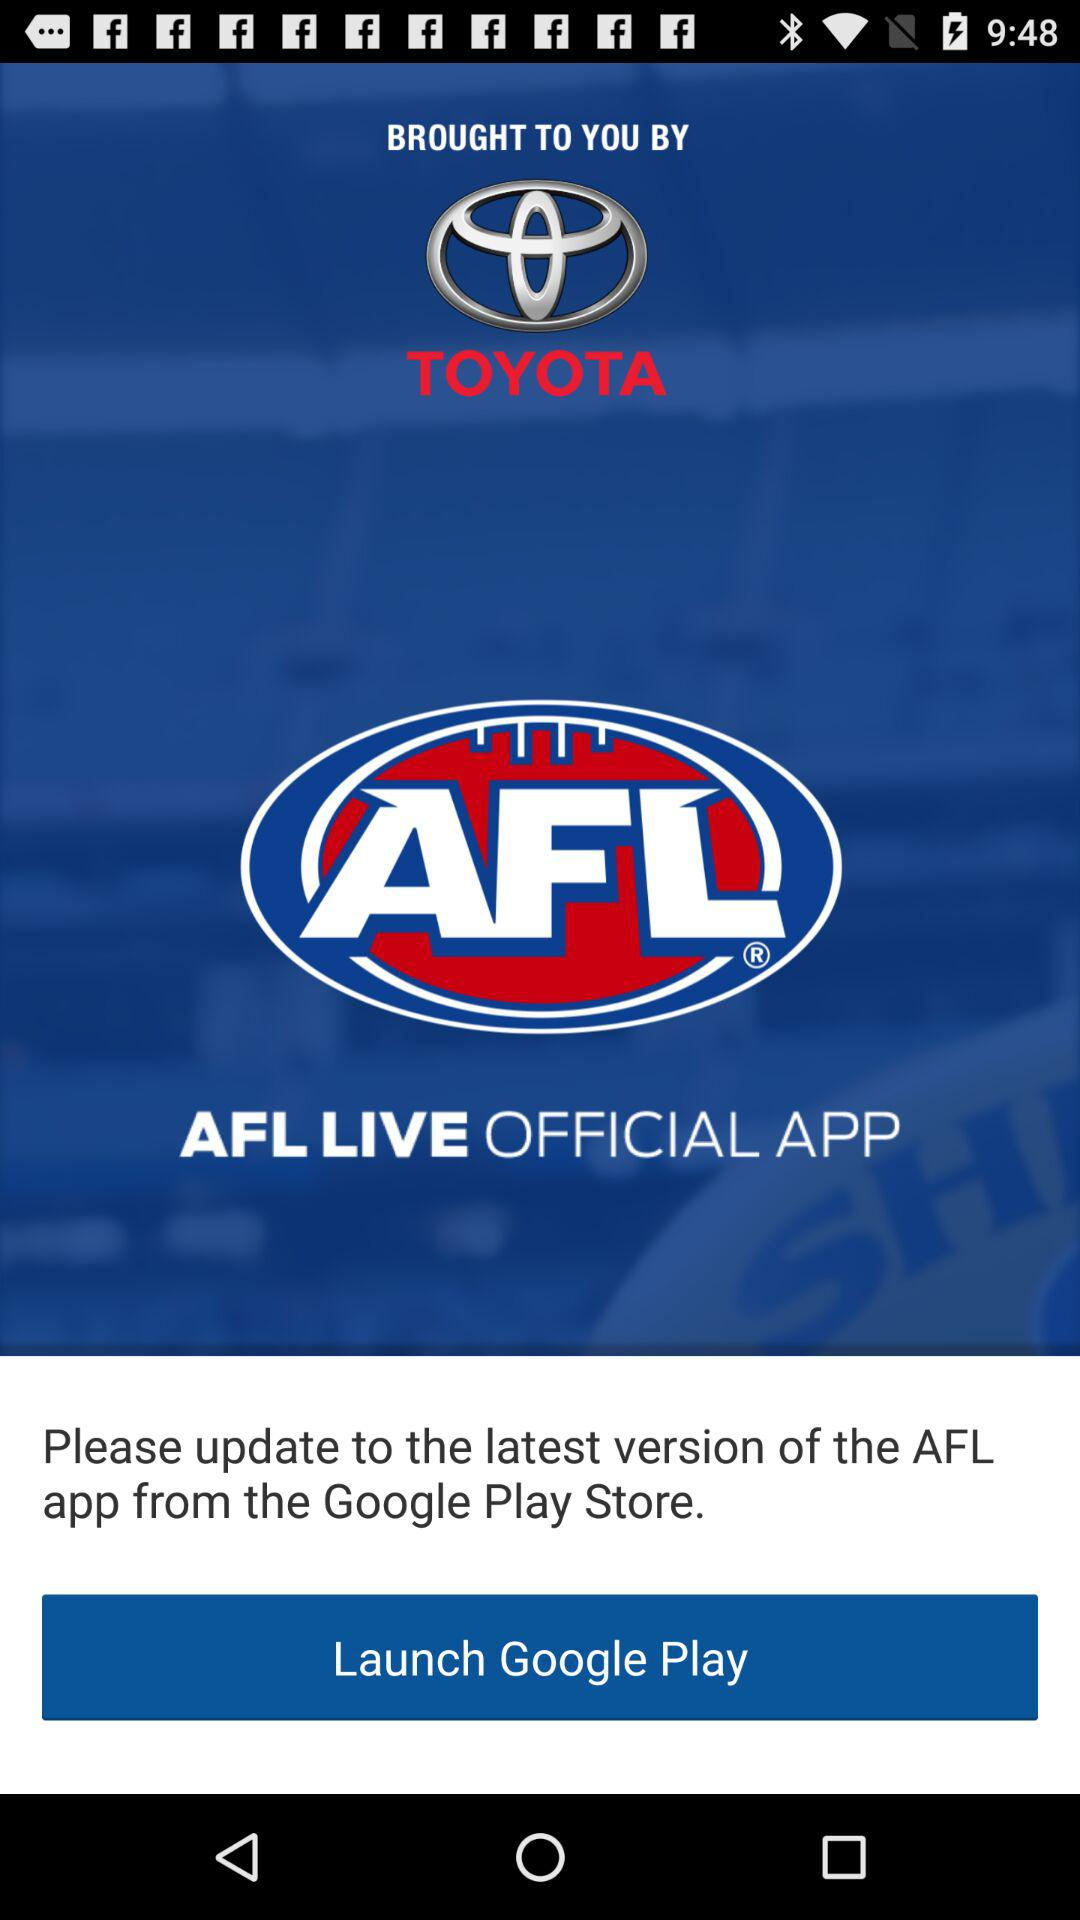When was the application updated to the latest version?
When the provided information is insufficient, respond with <no answer>. <no answer> 